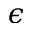Convert formula to latex. <formula><loc_0><loc_0><loc_500><loc_500>\epsilon</formula> 